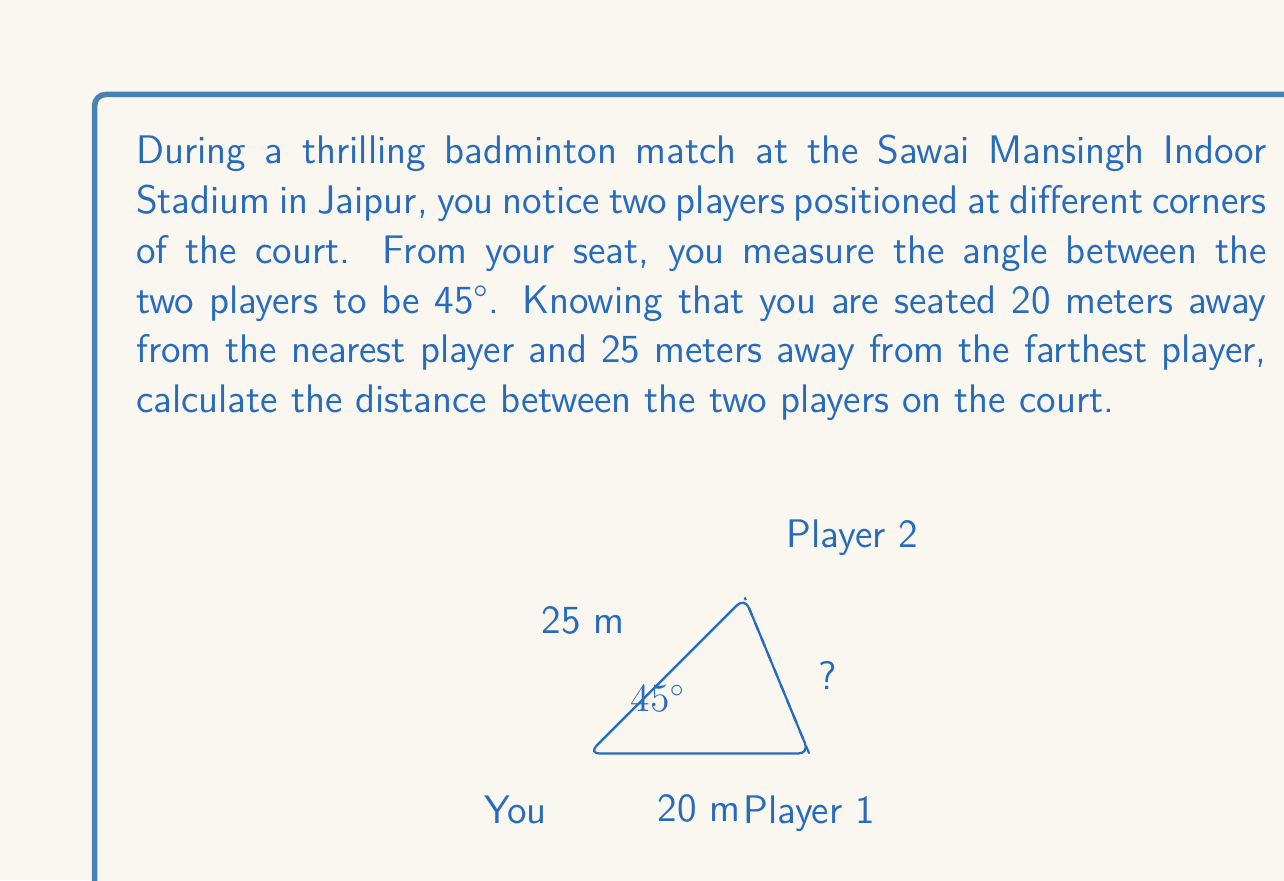Show me your answer to this math problem. Let's approach this step-by-step using the law of cosines:

1) Let's denote the distance between the two players as $x$.

2) We have a triangle with the following known information:
   - Side a = 20 meters (distance to nearest player)
   - Side b = 25 meters (distance to farthest player)
   - Angle C = 45° (angle between the two players from your position)

3) The law of cosines states:
   $$ c^2 = a^2 + b^2 - 2ab \cos(C) $$
   where $c$ is the side opposite to angle $C$.

4) In our case, $c$ is the distance between the players, which we denoted as $x$. So:
   $$ x^2 = 20^2 + 25^2 - 2(20)(25) \cos(45°) $$

5) Let's solve this step by step:
   $$ x^2 = 400 + 625 - 1000 \cos(45°) $$
   $$ x^2 = 1025 - 1000 (\frac{\sqrt{2}}{2}) $$
   $$ x^2 = 1025 - 500\sqrt{2} $$

6) Taking the square root of both sides:
   $$ x = \sqrt{1025 - 500\sqrt{2}} $$

7) Using a calculator to simplify:
   $$ x \approx 13.47 \text{ meters} $$

Therefore, the distance between the two players is approximately 13.47 meters.
Answer: The distance between the two badminton players is approximately 13.47 meters. 